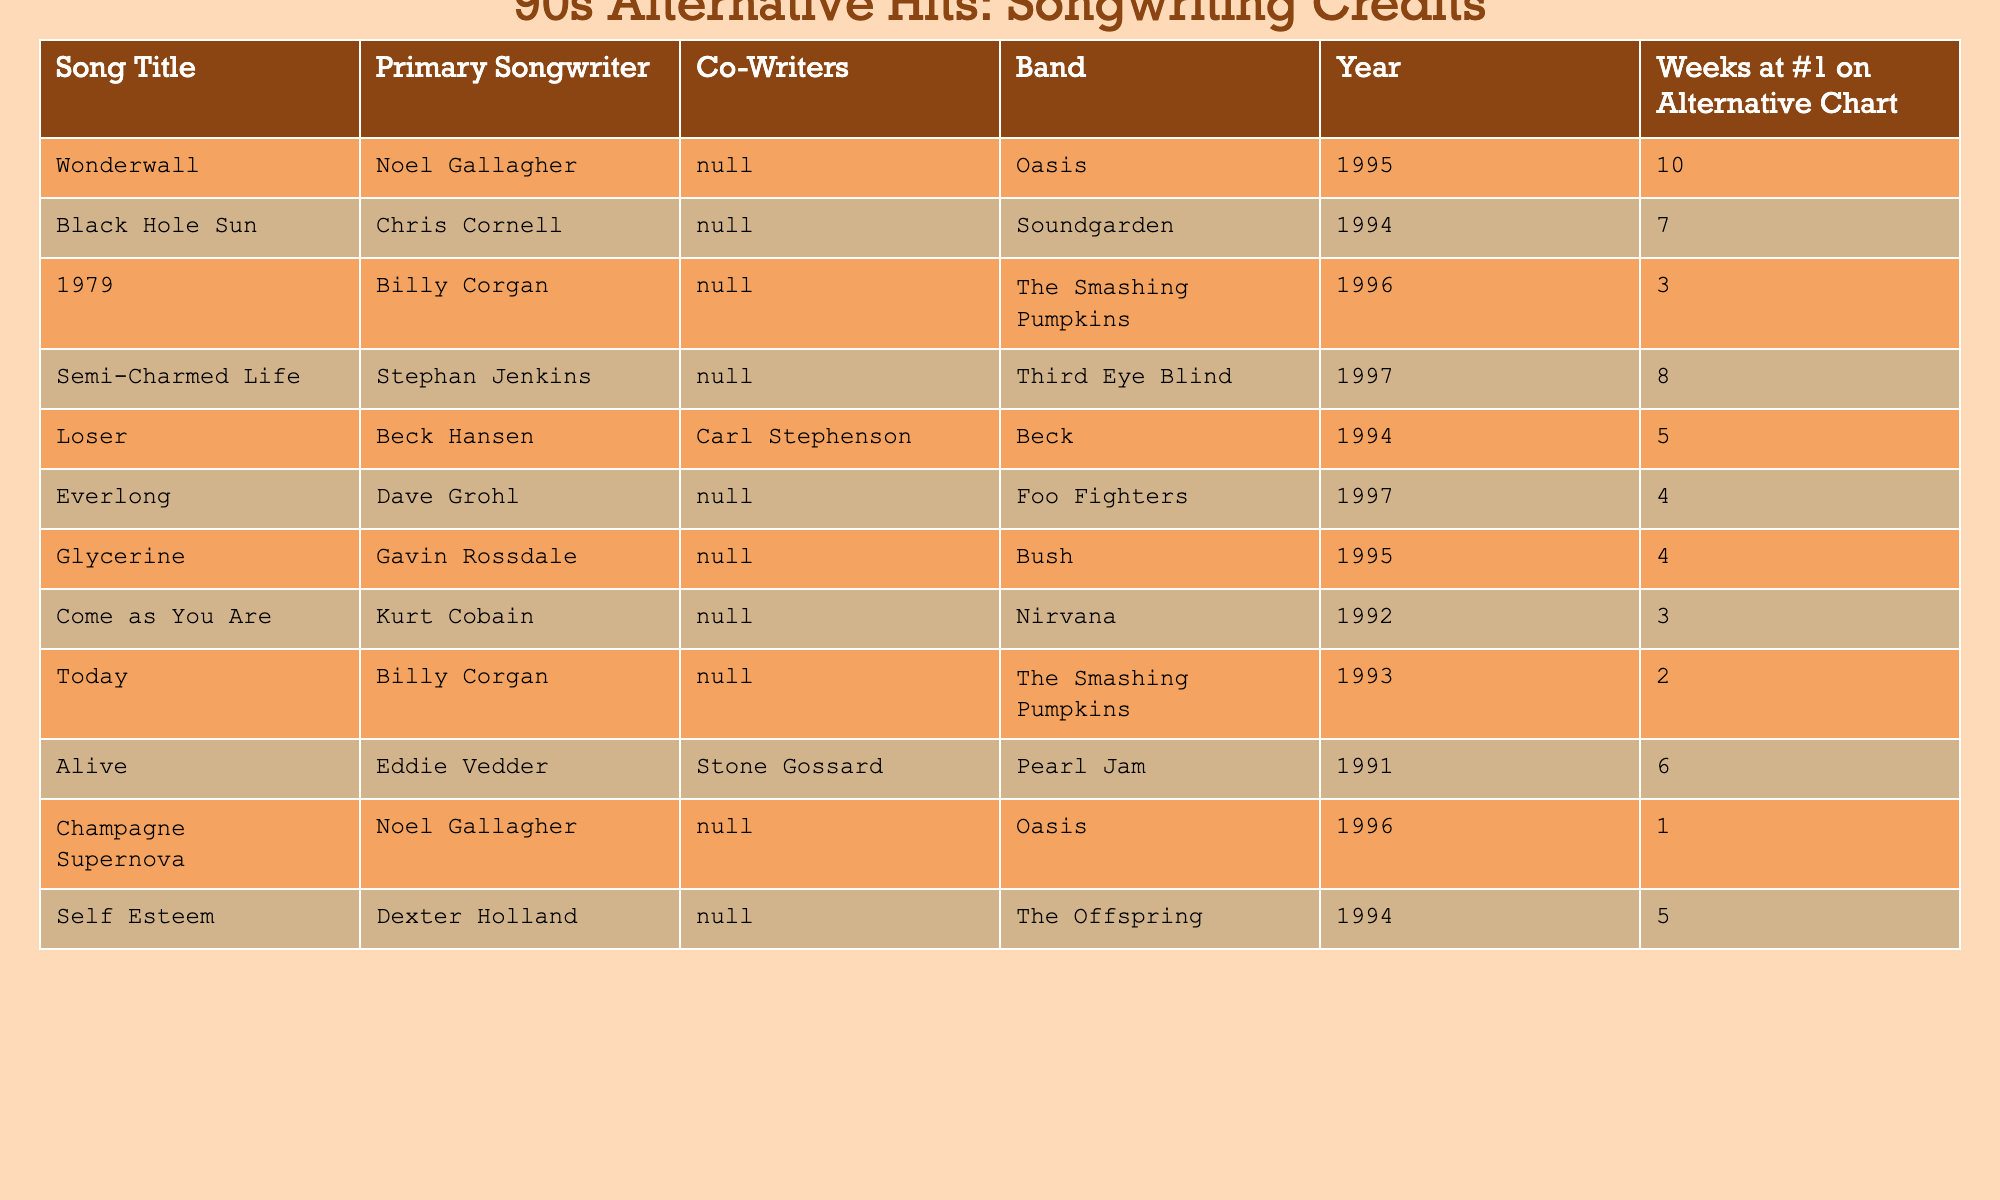What is the primary songwriter for "Wonderwall"? "Wonderwall" is listed in the table, and the primary songwriter for this song is Noel Gallagher.
Answer: Noel Gallagher Which song spent the most weeks at #1 on the Alternative Chart? By examining the "Weeks at #1 on Alternative Chart" column, "Wonderwall" has the highest value of 10 weeks.
Answer: "Wonderwall" Did "Alive" have a co-writer? The table indicates that "Alive" has a co-writer, Stone Gossard, listed under the "Co-Writers" column.
Answer: Yes Which artist wrote songs for both "1979" and "Today"? The primary songwriter for both songs is Billy Corgan, who is mentioned in the "Primary Songwriter" column for both entries.
Answer: Billy Corgan Which song has more weeks at #1, "Self Esteem" or "Loser"? Looking at the weeks at #1: "Self Esteem" has 5 weeks, while "Loser" has only 5 weeks as well; they are equal, so we compare both to find no difference.
Answer: They have the same amount (5 weeks) What is the average number of weeks at #1 for the songs written by Noel Gallagher? Noel Gallagher wrote two songs: "Wonderwall" with 10 weeks and "Champagne Supernova" with 1 week. The average is (10 + 1)/2 = 5.5.
Answer: 5.5 weeks How many songs on the table were written by a single songwriter without any co-writers? The table can be checked for songs where the "Co-Writers" column is empty. There are 6 such songs: "Black Hole Sun," "1979," "Semi-Charmed Life," "Everlong," "Glycerine," and "Come as You Are."
Answer: 6 Which band had the most songs authored by a single songwriter? By examining the table, The Smashing Pumpkins have two songs written by Billy Corgan, while all other bands have either one or two songs spread among different songwriters.
Answer: The Smashing Pumpkins Was there any song from 1992 that reached #1 on the Alternative Chart? Checking the "Year" column, the only song from 1992 is "Come as You Are," which did not reach #1 (it has 3 weeks total).
Answer: No If you add the weeks at #1 for the songs by Dave Grohl, what do you get? Dave Grohl is listed as the primary songwriter for "Everlong," which had 4 weeks at #1. There are no other songs by Grohl in the table, so the total is 4.
Answer: 4 weeks 